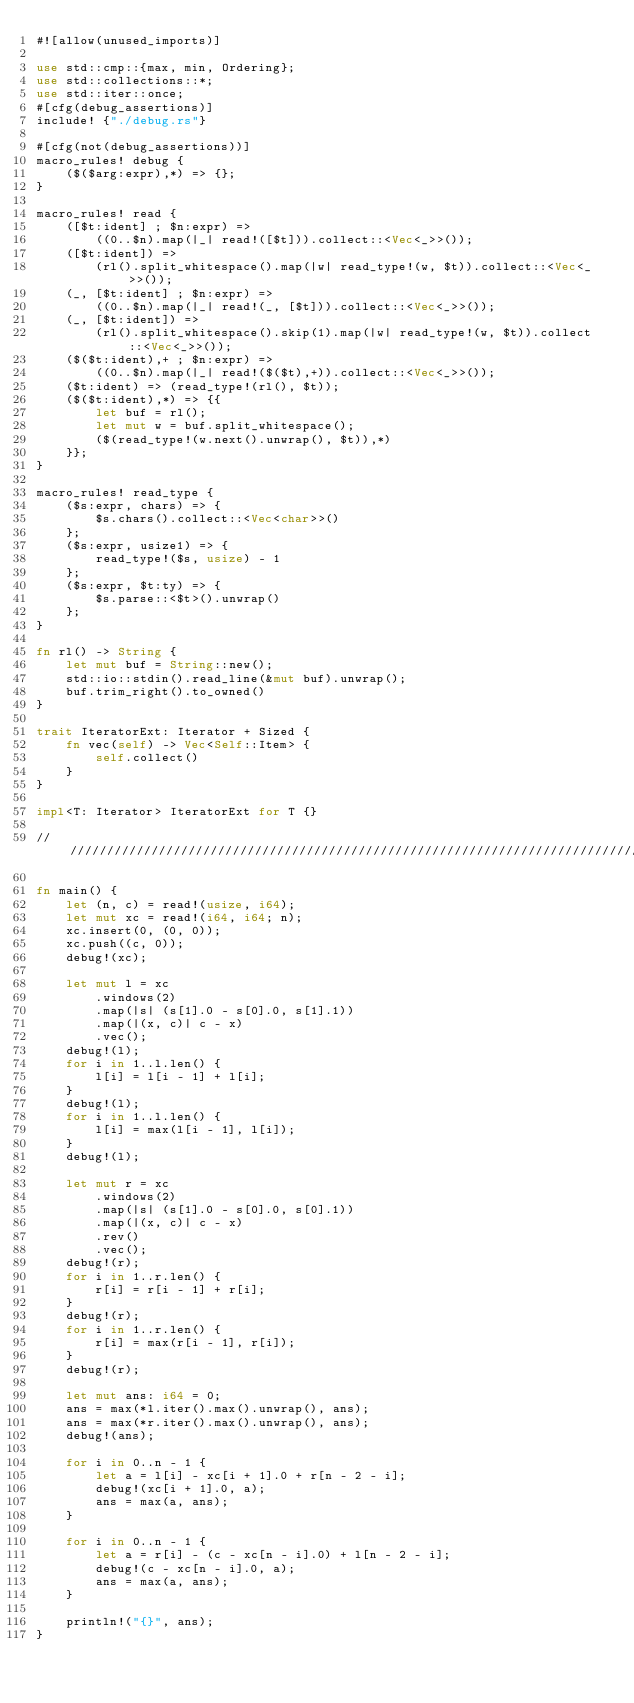<code> <loc_0><loc_0><loc_500><loc_500><_Rust_>#![allow(unused_imports)]

use std::cmp::{max, min, Ordering};
use std::collections::*;
use std::iter::once;
#[cfg(debug_assertions)]
include! {"./debug.rs"}

#[cfg(not(debug_assertions))]
macro_rules! debug {
    ($($arg:expr),*) => {};
}

macro_rules! read {
    ([$t:ident] ; $n:expr) =>
        ((0..$n).map(|_| read!([$t])).collect::<Vec<_>>());
    ([$t:ident]) =>
        (rl().split_whitespace().map(|w| read_type!(w, $t)).collect::<Vec<_>>());
    (_, [$t:ident] ; $n:expr) =>
        ((0..$n).map(|_| read!(_, [$t])).collect::<Vec<_>>());
    (_, [$t:ident]) =>
        (rl().split_whitespace().skip(1).map(|w| read_type!(w, $t)).collect::<Vec<_>>());
    ($($t:ident),+ ; $n:expr) =>
        ((0..$n).map(|_| read!($($t),+)).collect::<Vec<_>>());
    ($t:ident) => (read_type!(rl(), $t));
    ($($t:ident),*) => {{
        let buf = rl();
        let mut w = buf.split_whitespace();
        ($(read_type!(w.next().unwrap(), $t)),*)
    }};
}

macro_rules! read_type {
    ($s:expr, chars) => {
        $s.chars().collect::<Vec<char>>()
    };
    ($s:expr, usize1) => {
        read_type!($s, usize) - 1
    };
    ($s:expr, $t:ty) => {
        $s.parse::<$t>().unwrap()
    };
}

fn rl() -> String {
    let mut buf = String::new();
    std::io::stdin().read_line(&mut buf).unwrap();
    buf.trim_right().to_owned()
}

trait IteratorExt: Iterator + Sized {
    fn vec(self) -> Vec<Self::Item> {
        self.collect()
    }
}

impl<T: Iterator> IteratorExt for T {}

////////////////////////////////////////////////////////////////////////////////

fn main() {
    let (n, c) = read!(usize, i64);
    let mut xc = read!(i64, i64; n);
    xc.insert(0, (0, 0));
    xc.push((c, 0));
    debug!(xc);

    let mut l = xc
        .windows(2)
        .map(|s| (s[1].0 - s[0].0, s[1].1))
        .map(|(x, c)| c - x)
        .vec();
    debug!(l);
    for i in 1..l.len() {
        l[i] = l[i - 1] + l[i];
    }
    debug!(l);
    for i in 1..l.len() {
        l[i] = max(l[i - 1], l[i]);
    }
    debug!(l);

    let mut r = xc
        .windows(2)
        .map(|s| (s[1].0 - s[0].0, s[0].1))
        .map(|(x, c)| c - x)
        .rev()
        .vec();
    debug!(r);
    for i in 1..r.len() {
        r[i] = r[i - 1] + r[i];
    }
    debug!(r);
    for i in 1..r.len() {
        r[i] = max(r[i - 1], r[i]);
    }
    debug!(r);

    let mut ans: i64 = 0;
    ans = max(*l.iter().max().unwrap(), ans);
    ans = max(*r.iter().max().unwrap(), ans);
    debug!(ans);

    for i in 0..n - 1 {
        let a = l[i] - xc[i + 1].0 + r[n - 2 - i];
        debug!(xc[i + 1].0, a);
        ans = max(a, ans);
    }

    for i in 0..n - 1 {
        let a = r[i] - (c - xc[n - i].0) + l[n - 2 - i];
        debug!(c - xc[n - i].0, a);
        ans = max(a, ans);
    }

    println!("{}", ans);
}
</code> 